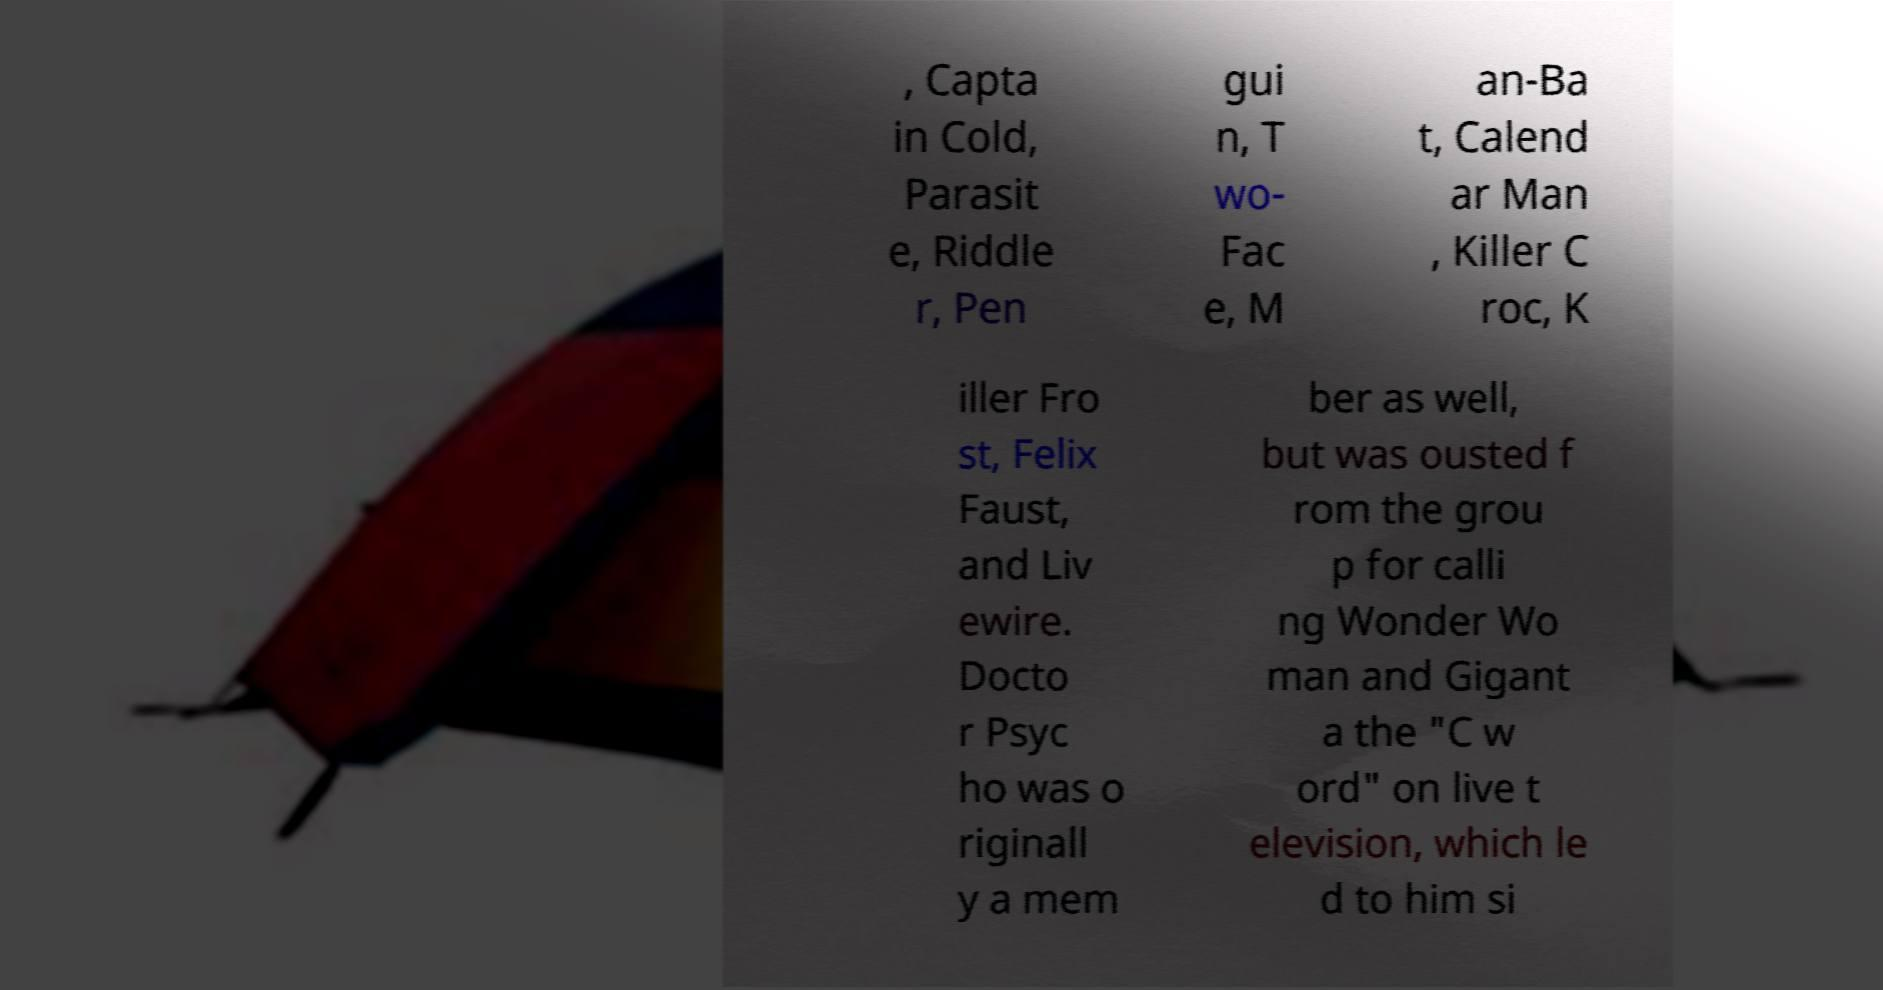Can you read and provide the text displayed in the image?This photo seems to have some interesting text. Can you extract and type it out for me? , Capta in Cold, Parasit e, Riddle r, Pen gui n, T wo- Fac e, M an-Ba t, Calend ar Man , Killer C roc, K iller Fro st, Felix Faust, and Liv ewire. Docto r Psyc ho was o riginall y a mem ber as well, but was ousted f rom the grou p for calli ng Wonder Wo man and Gigant a the "C w ord" on live t elevision, which le d to him si 